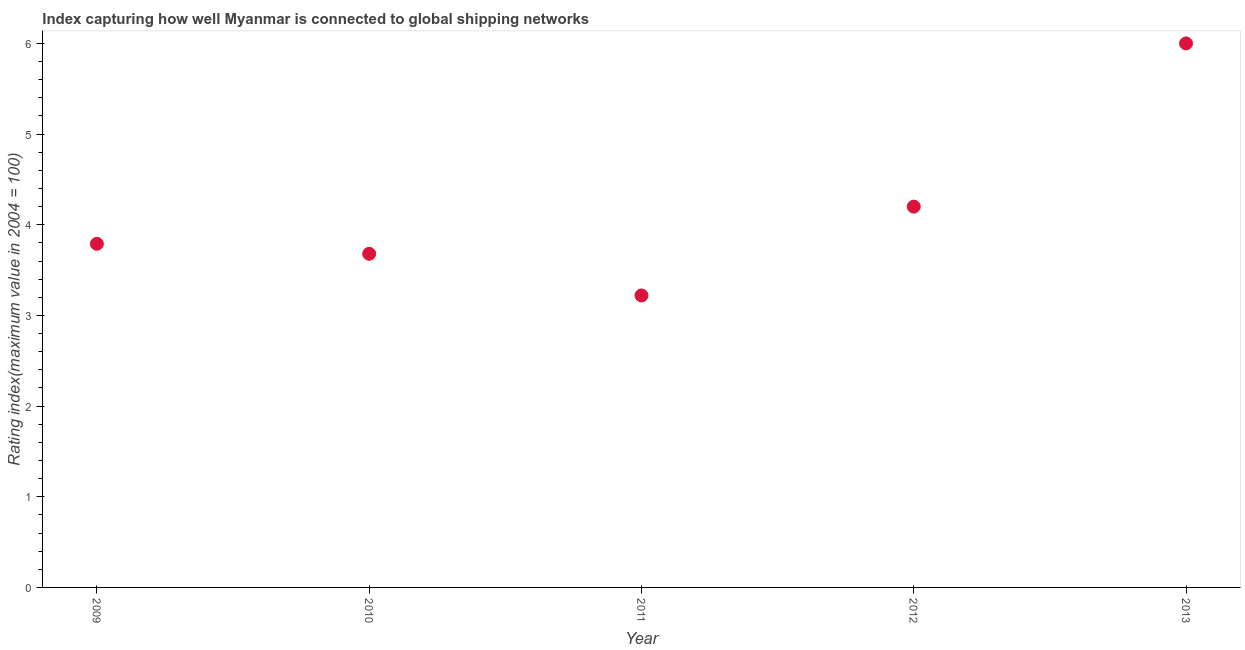What is the liner shipping connectivity index in 2013?
Keep it short and to the point. 6. Across all years, what is the minimum liner shipping connectivity index?
Your response must be concise. 3.22. In which year was the liner shipping connectivity index minimum?
Make the answer very short. 2011. What is the sum of the liner shipping connectivity index?
Offer a terse response. 20.89. What is the difference between the liner shipping connectivity index in 2009 and 2011?
Provide a short and direct response. 0.57. What is the average liner shipping connectivity index per year?
Keep it short and to the point. 4.18. What is the median liner shipping connectivity index?
Offer a terse response. 3.79. Do a majority of the years between 2011 and 2010 (inclusive) have liner shipping connectivity index greater than 3.8 ?
Ensure brevity in your answer.  No. What is the ratio of the liner shipping connectivity index in 2011 to that in 2012?
Your response must be concise. 0.77. Is the liner shipping connectivity index in 2011 less than that in 2012?
Keep it short and to the point. Yes. Is the difference between the liner shipping connectivity index in 2012 and 2013 greater than the difference between any two years?
Your answer should be very brief. No. What is the difference between the highest and the second highest liner shipping connectivity index?
Your answer should be very brief. 1.8. Is the sum of the liner shipping connectivity index in 2010 and 2013 greater than the maximum liner shipping connectivity index across all years?
Make the answer very short. Yes. What is the difference between the highest and the lowest liner shipping connectivity index?
Your answer should be very brief. 2.78. How many years are there in the graph?
Your answer should be very brief. 5. What is the difference between two consecutive major ticks on the Y-axis?
Your response must be concise. 1. Does the graph contain any zero values?
Provide a short and direct response. No. Does the graph contain grids?
Provide a short and direct response. No. What is the title of the graph?
Make the answer very short. Index capturing how well Myanmar is connected to global shipping networks. What is the label or title of the X-axis?
Your answer should be compact. Year. What is the label or title of the Y-axis?
Keep it short and to the point. Rating index(maximum value in 2004 = 100). What is the Rating index(maximum value in 2004 = 100) in 2009?
Your answer should be compact. 3.79. What is the Rating index(maximum value in 2004 = 100) in 2010?
Make the answer very short. 3.68. What is the Rating index(maximum value in 2004 = 100) in 2011?
Keep it short and to the point. 3.22. What is the Rating index(maximum value in 2004 = 100) in 2012?
Provide a short and direct response. 4.2. What is the difference between the Rating index(maximum value in 2004 = 100) in 2009 and 2010?
Your response must be concise. 0.11. What is the difference between the Rating index(maximum value in 2004 = 100) in 2009 and 2011?
Offer a very short reply. 0.57. What is the difference between the Rating index(maximum value in 2004 = 100) in 2009 and 2012?
Make the answer very short. -0.41. What is the difference between the Rating index(maximum value in 2004 = 100) in 2009 and 2013?
Ensure brevity in your answer.  -2.21. What is the difference between the Rating index(maximum value in 2004 = 100) in 2010 and 2011?
Make the answer very short. 0.46. What is the difference between the Rating index(maximum value in 2004 = 100) in 2010 and 2012?
Offer a terse response. -0.52. What is the difference between the Rating index(maximum value in 2004 = 100) in 2010 and 2013?
Provide a short and direct response. -2.32. What is the difference between the Rating index(maximum value in 2004 = 100) in 2011 and 2012?
Your response must be concise. -0.98. What is the difference between the Rating index(maximum value in 2004 = 100) in 2011 and 2013?
Ensure brevity in your answer.  -2.78. What is the ratio of the Rating index(maximum value in 2004 = 100) in 2009 to that in 2011?
Provide a succinct answer. 1.18. What is the ratio of the Rating index(maximum value in 2004 = 100) in 2009 to that in 2012?
Provide a succinct answer. 0.9. What is the ratio of the Rating index(maximum value in 2004 = 100) in 2009 to that in 2013?
Give a very brief answer. 0.63. What is the ratio of the Rating index(maximum value in 2004 = 100) in 2010 to that in 2011?
Offer a very short reply. 1.14. What is the ratio of the Rating index(maximum value in 2004 = 100) in 2010 to that in 2012?
Offer a terse response. 0.88. What is the ratio of the Rating index(maximum value in 2004 = 100) in 2010 to that in 2013?
Offer a terse response. 0.61. What is the ratio of the Rating index(maximum value in 2004 = 100) in 2011 to that in 2012?
Ensure brevity in your answer.  0.77. What is the ratio of the Rating index(maximum value in 2004 = 100) in 2011 to that in 2013?
Offer a very short reply. 0.54. What is the ratio of the Rating index(maximum value in 2004 = 100) in 2012 to that in 2013?
Offer a very short reply. 0.7. 